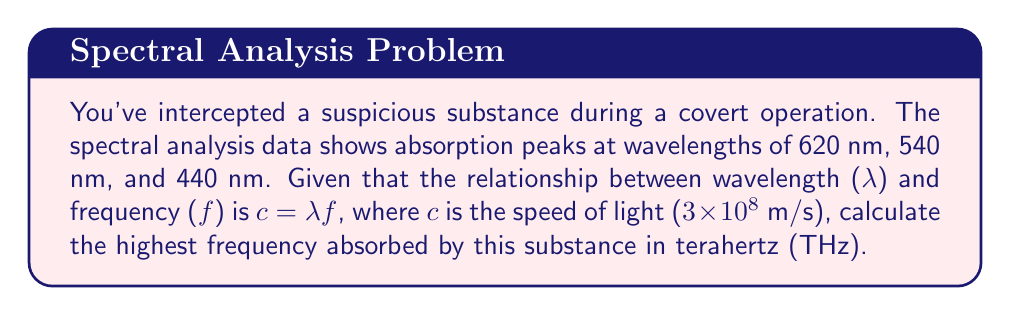Give your solution to this math problem. To solve this problem, we'll follow these steps:

1) Recall the formula relating wavelength and frequency:
   $$c = \lambda f$$
   where $c$ is the speed of light, $\lambda$ is wavelength, and $f$ is frequency.

2) Rearrange the formula to solve for frequency:
   $$f = \frac{c}{\lambda}$$

3) We need to find the highest frequency, which corresponds to the shortest wavelength. The shortest wavelength given is 440 nm.

4) Convert 440 nm to meters:
   $$440 \text{ nm} = 440 \times 10^{-9} \text{ m}$$

5) Substitute the values into the formula:
   $$f = \frac{3 \times 10^8 \text{ m/s}}{440 \times 10^{-9} \text{ m}}$$

6) Calculate:
   $$f = 6.82 \times 10^{14} \text{ Hz}$$

7) Convert to terahertz (THz):
   $$6.82 \times 10^{14} \text{ Hz} = 682 \text{ THz}$$
Answer: 682 THz 